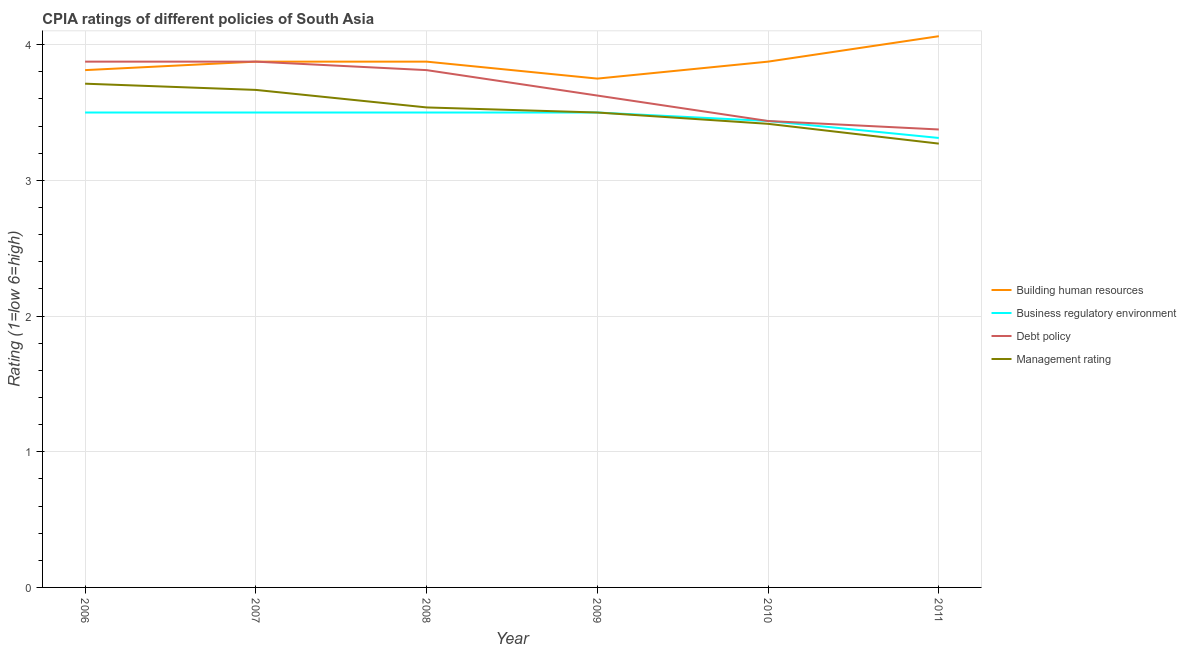How many different coloured lines are there?
Your answer should be compact. 4. Does the line corresponding to cpia rating of management intersect with the line corresponding to cpia rating of building human resources?
Your response must be concise. No. Is the number of lines equal to the number of legend labels?
Your response must be concise. Yes. What is the cpia rating of building human resources in 2010?
Offer a terse response. 3.88. Across all years, what is the minimum cpia rating of debt policy?
Provide a short and direct response. 3.38. What is the total cpia rating of business regulatory environment in the graph?
Keep it short and to the point. 20.75. What is the difference between the cpia rating of debt policy in 2008 and that in 2009?
Offer a terse response. 0.19. What is the difference between the cpia rating of business regulatory environment in 2007 and the cpia rating of management in 2008?
Ensure brevity in your answer.  -0.04. What is the average cpia rating of building human resources per year?
Provide a short and direct response. 3.88. In the year 2009, what is the difference between the cpia rating of business regulatory environment and cpia rating of management?
Keep it short and to the point. 0. In how many years, is the cpia rating of building human resources greater than 3.8?
Make the answer very short. 5. What is the ratio of the cpia rating of building human resources in 2010 to that in 2011?
Provide a short and direct response. 0.95. What is the difference between the highest and the lowest cpia rating of management?
Keep it short and to the point. 0.44. Is the sum of the cpia rating of building human resources in 2006 and 2011 greater than the maximum cpia rating of management across all years?
Your answer should be very brief. Yes. Is it the case that in every year, the sum of the cpia rating of management and cpia rating of debt policy is greater than the sum of cpia rating of building human resources and cpia rating of business regulatory environment?
Your response must be concise. No. Is the cpia rating of management strictly less than the cpia rating of debt policy over the years?
Offer a very short reply. Yes. How many lines are there?
Keep it short and to the point. 4. Are the values on the major ticks of Y-axis written in scientific E-notation?
Offer a terse response. No. Does the graph contain any zero values?
Offer a very short reply. No. Does the graph contain grids?
Provide a succinct answer. Yes. Where does the legend appear in the graph?
Ensure brevity in your answer.  Center right. How many legend labels are there?
Your answer should be compact. 4. What is the title of the graph?
Offer a very short reply. CPIA ratings of different policies of South Asia. What is the label or title of the X-axis?
Offer a terse response. Year. What is the Rating (1=low 6=high) in Building human resources in 2006?
Your answer should be compact. 3.81. What is the Rating (1=low 6=high) of Debt policy in 2006?
Keep it short and to the point. 3.88. What is the Rating (1=low 6=high) in Management rating in 2006?
Keep it short and to the point. 3.71. What is the Rating (1=low 6=high) in Building human resources in 2007?
Your response must be concise. 3.88. What is the Rating (1=low 6=high) in Debt policy in 2007?
Ensure brevity in your answer.  3.88. What is the Rating (1=low 6=high) in Management rating in 2007?
Your answer should be very brief. 3.67. What is the Rating (1=low 6=high) in Building human resources in 2008?
Provide a succinct answer. 3.88. What is the Rating (1=low 6=high) of Business regulatory environment in 2008?
Keep it short and to the point. 3.5. What is the Rating (1=low 6=high) in Debt policy in 2008?
Offer a terse response. 3.81. What is the Rating (1=low 6=high) in Management rating in 2008?
Give a very brief answer. 3.54. What is the Rating (1=low 6=high) of Building human resources in 2009?
Give a very brief answer. 3.75. What is the Rating (1=low 6=high) in Business regulatory environment in 2009?
Keep it short and to the point. 3.5. What is the Rating (1=low 6=high) of Debt policy in 2009?
Ensure brevity in your answer.  3.62. What is the Rating (1=low 6=high) of Management rating in 2009?
Keep it short and to the point. 3.5. What is the Rating (1=low 6=high) of Building human resources in 2010?
Your answer should be very brief. 3.88. What is the Rating (1=low 6=high) in Business regulatory environment in 2010?
Offer a very short reply. 3.44. What is the Rating (1=low 6=high) of Debt policy in 2010?
Make the answer very short. 3.44. What is the Rating (1=low 6=high) in Management rating in 2010?
Your answer should be very brief. 3.42. What is the Rating (1=low 6=high) of Building human resources in 2011?
Provide a succinct answer. 4.06. What is the Rating (1=low 6=high) of Business regulatory environment in 2011?
Provide a short and direct response. 3.31. What is the Rating (1=low 6=high) of Debt policy in 2011?
Your response must be concise. 3.38. What is the Rating (1=low 6=high) of Management rating in 2011?
Offer a very short reply. 3.27. Across all years, what is the maximum Rating (1=low 6=high) of Building human resources?
Your answer should be very brief. 4.06. Across all years, what is the maximum Rating (1=low 6=high) in Business regulatory environment?
Offer a terse response. 3.5. Across all years, what is the maximum Rating (1=low 6=high) of Debt policy?
Make the answer very short. 3.88. Across all years, what is the maximum Rating (1=low 6=high) of Management rating?
Offer a terse response. 3.71. Across all years, what is the minimum Rating (1=low 6=high) of Building human resources?
Offer a terse response. 3.75. Across all years, what is the minimum Rating (1=low 6=high) in Business regulatory environment?
Your answer should be compact. 3.31. Across all years, what is the minimum Rating (1=low 6=high) in Debt policy?
Give a very brief answer. 3.38. Across all years, what is the minimum Rating (1=low 6=high) in Management rating?
Give a very brief answer. 3.27. What is the total Rating (1=low 6=high) in Building human resources in the graph?
Provide a succinct answer. 23.25. What is the total Rating (1=low 6=high) of Business regulatory environment in the graph?
Give a very brief answer. 20.75. What is the total Rating (1=low 6=high) in Management rating in the graph?
Your answer should be very brief. 21.1. What is the difference between the Rating (1=low 6=high) in Building human resources in 2006 and that in 2007?
Your response must be concise. -0.06. What is the difference between the Rating (1=low 6=high) in Business regulatory environment in 2006 and that in 2007?
Give a very brief answer. 0. What is the difference between the Rating (1=low 6=high) of Management rating in 2006 and that in 2007?
Your response must be concise. 0.05. What is the difference between the Rating (1=low 6=high) in Building human resources in 2006 and that in 2008?
Your response must be concise. -0.06. What is the difference between the Rating (1=low 6=high) in Business regulatory environment in 2006 and that in 2008?
Your answer should be compact. 0. What is the difference between the Rating (1=low 6=high) of Debt policy in 2006 and that in 2008?
Offer a very short reply. 0.06. What is the difference between the Rating (1=low 6=high) of Management rating in 2006 and that in 2008?
Provide a short and direct response. 0.17. What is the difference between the Rating (1=low 6=high) of Building human resources in 2006 and that in 2009?
Offer a very short reply. 0.06. What is the difference between the Rating (1=low 6=high) in Debt policy in 2006 and that in 2009?
Provide a succinct answer. 0.25. What is the difference between the Rating (1=low 6=high) of Management rating in 2006 and that in 2009?
Your response must be concise. 0.21. What is the difference between the Rating (1=low 6=high) of Building human resources in 2006 and that in 2010?
Offer a very short reply. -0.06. What is the difference between the Rating (1=low 6=high) in Business regulatory environment in 2006 and that in 2010?
Give a very brief answer. 0.06. What is the difference between the Rating (1=low 6=high) in Debt policy in 2006 and that in 2010?
Provide a short and direct response. 0.44. What is the difference between the Rating (1=low 6=high) of Management rating in 2006 and that in 2010?
Offer a very short reply. 0.3. What is the difference between the Rating (1=low 6=high) of Building human resources in 2006 and that in 2011?
Your response must be concise. -0.25. What is the difference between the Rating (1=low 6=high) of Business regulatory environment in 2006 and that in 2011?
Ensure brevity in your answer.  0.19. What is the difference between the Rating (1=low 6=high) of Management rating in 2006 and that in 2011?
Your answer should be compact. 0.44. What is the difference between the Rating (1=low 6=high) of Debt policy in 2007 and that in 2008?
Give a very brief answer. 0.06. What is the difference between the Rating (1=low 6=high) in Management rating in 2007 and that in 2008?
Provide a short and direct response. 0.13. What is the difference between the Rating (1=low 6=high) in Business regulatory environment in 2007 and that in 2009?
Your response must be concise. 0. What is the difference between the Rating (1=low 6=high) in Debt policy in 2007 and that in 2009?
Provide a succinct answer. 0.25. What is the difference between the Rating (1=low 6=high) of Business regulatory environment in 2007 and that in 2010?
Offer a very short reply. 0.06. What is the difference between the Rating (1=low 6=high) of Debt policy in 2007 and that in 2010?
Offer a terse response. 0.44. What is the difference between the Rating (1=low 6=high) in Building human resources in 2007 and that in 2011?
Your response must be concise. -0.19. What is the difference between the Rating (1=low 6=high) in Business regulatory environment in 2007 and that in 2011?
Offer a terse response. 0.19. What is the difference between the Rating (1=low 6=high) in Debt policy in 2007 and that in 2011?
Your answer should be compact. 0.5. What is the difference between the Rating (1=low 6=high) of Management rating in 2007 and that in 2011?
Keep it short and to the point. 0.4. What is the difference between the Rating (1=low 6=high) in Building human resources in 2008 and that in 2009?
Make the answer very short. 0.12. What is the difference between the Rating (1=low 6=high) in Business regulatory environment in 2008 and that in 2009?
Offer a terse response. 0. What is the difference between the Rating (1=low 6=high) in Debt policy in 2008 and that in 2009?
Provide a succinct answer. 0.19. What is the difference between the Rating (1=low 6=high) of Management rating in 2008 and that in 2009?
Keep it short and to the point. 0.04. What is the difference between the Rating (1=low 6=high) of Building human resources in 2008 and that in 2010?
Your answer should be very brief. 0. What is the difference between the Rating (1=low 6=high) in Business regulatory environment in 2008 and that in 2010?
Your answer should be very brief. 0.06. What is the difference between the Rating (1=low 6=high) in Debt policy in 2008 and that in 2010?
Ensure brevity in your answer.  0.38. What is the difference between the Rating (1=low 6=high) in Management rating in 2008 and that in 2010?
Offer a very short reply. 0.12. What is the difference between the Rating (1=low 6=high) of Building human resources in 2008 and that in 2011?
Offer a terse response. -0.19. What is the difference between the Rating (1=low 6=high) in Business regulatory environment in 2008 and that in 2011?
Provide a short and direct response. 0.19. What is the difference between the Rating (1=low 6=high) of Debt policy in 2008 and that in 2011?
Your answer should be very brief. 0.44. What is the difference between the Rating (1=low 6=high) in Management rating in 2008 and that in 2011?
Ensure brevity in your answer.  0.27. What is the difference between the Rating (1=low 6=high) in Building human resources in 2009 and that in 2010?
Offer a very short reply. -0.12. What is the difference between the Rating (1=low 6=high) of Business regulatory environment in 2009 and that in 2010?
Give a very brief answer. 0.06. What is the difference between the Rating (1=low 6=high) in Debt policy in 2009 and that in 2010?
Your answer should be very brief. 0.19. What is the difference between the Rating (1=low 6=high) of Management rating in 2009 and that in 2010?
Offer a terse response. 0.08. What is the difference between the Rating (1=low 6=high) of Building human resources in 2009 and that in 2011?
Offer a terse response. -0.31. What is the difference between the Rating (1=low 6=high) of Business regulatory environment in 2009 and that in 2011?
Offer a terse response. 0.19. What is the difference between the Rating (1=low 6=high) in Management rating in 2009 and that in 2011?
Make the answer very short. 0.23. What is the difference between the Rating (1=low 6=high) in Building human resources in 2010 and that in 2011?
Ensure brevity in your answer.  -0.19. What is the difference between the Rating (1=low 6=high) in Business regulatory environment in 2010 and that in 2011?
Your answer should be compact. 0.12. What is the difference between the Rating (1=low 6=high) of Debt policy in 2010 and that in 2011?
Your response must be concise. 0.06. What is the difference between the Rating (1=low 6=high) of Management rating in 2010 and that in 2011?
Give a very brief answer. 0.15. What is the difference between the Rating (1=low 6=high) of Building human resources in 2006 and the Rating (1=low 6=high) of Business regulatory environment in 2007?
Keep it short and to the point. 0.31. What is the difference between the Rating (1=low 6=high) in Building human resources in 2006 and the Rating (1=low 6=high) in Debt policy in 2007?
Give a very brief answer. -0.06. What is the difference between the Rating (1=low 6=high) in Building human resources in 2006 and the Rating (1=low 6=high) in Management rating in 2007?
Offer a terse response. 0.15. What is the difference between the Rating (1=low 6=high) in Business regulatory environment in 2006 and the Rating (1=low 6=high) in Debt policy in 2007?
Ensure brevity in your answer.  -0.38. What is the difference between the Rating (1=low 6=high) in Business regulatory environment in 2006 and the Rating (1=low 6=high) in Management rating in 2007?
Your answer should be compact. -0.17. What is the difference between the Rating (1=low 6=high) of Debt policy in 2006 and the Rating (1=low 6=high) of Management rating in 2007?
Give a very brief answer. 0.21. What is the difference between the Rating (1=low 6=high) of Building human resources in 2006 and the Rating (1=low 6=high) of Business regulatory environment in 2008?
Offer a terse response. 0.31. What is the difference between the Rating (1=low 6=high) in Building human resources in 2006 and the Rating (1=low 6=high) in Debt policy in 2008?
Offer a very short reply. 0. What is the difference between the Rating (1=low 6=high) in Building human resources in 2006 and the Rating (1=low 6=high) in Management rating in 2008?
Provide a short and direct response. 0.28. What is the difference between the Rating (1=low 6=high) in Business regulatory environment in 2006 and the Rating (1=low 6=high) in Debt policy in 2008?
Offer a terse response. -0.31. What is the difference between the Rating (1=low 6=high) in Business regulatory environment in 2006 and the Rating (1=low 6=high) in Management rating in 2008?
Your response must be concise. -0.04. What is the difference between the Rating (1=low 6=high) of Debt policy in 2006 and the Rating (1=low 6=high) of Management rating in 2008?
Your response must be concise. 0.34. What is the difference between the Rating (1=low 6=high) in Building human resources in 2006 and the Rating (1=low 6=high) in Business regulatory environment in 2009?
Give a very brief answer. 0.31. What is the difference between the Rating (1=low 6=high) in Building human resources in 2006 and the Rating (1=low 6=high) in Debt policy in 2009?
Keep it short and to the point. 0.19. What is the difference between the Rating (1=low 6=high) of Building human resources in 2006 and the Rating (1=low 6=high) of Management rating in 2009?
Your answer should be compact. 0.31. What is the difference between the Rating (1=low 6=high) in Business regulatory environment in 2006 and the Rating (1=low 6=high) in Debt policy in 2009?
Offer a terse response. -0.12. What is the difference between the Rating (1=low 6=high) in Building human resources in 2006 and the Rating (1=low 6=high) in Business regulatory environment in 2010?
Your answer should be compact. 0.38. What is the difference between the Rating (1=low 6=high) in Building human resources in 2006 and the Rating (1=low 6=high) in Debt policy in 2010?
Your response must be concise. 0.38. What is the difference between the Rating (1=low 6=high) of Building human resources in 2006 and the Rating (1=low 6=high) of Management rating in 2010?
Your response must be concise. 0.4. What is the difference between the Rating (1=low 6=high) of Business regulatory environment in 2006 and the Rating (1=low 6=high) of Debt policy in 2010?
Your response must be concise. 0.06. What is the difference between the Rating (1=low 6=high) of Business regulatory environment in 2006 and the Rating (1=low 6=high) of Management rating in 2010?
Your answer should be very brief. 0.08. What is the difference between the Rating (1=low 6=high) of Debt policy in 2006 and the Rating (1=low 6=high) of Management rating in 2010?
Your answer should be very brief. 0.46. What is the difference between the Rating (1=low 6=high) of Building human resources in 2006 and the Rating (1=low 6=high) of Debt policy in 2011?
Provide a short and direct response. 0.44. What is the difference between the Rating (1=low 6=high) in Building human resources in 2006 and the Rating (1=low 6=high) in Management rating in 2011?
Offer a terse response. 0.54. What is the difference between the Rating (1=low 6=high) in Business regulatory environment in 2006 and the Rating (1=low 6=high) in Debt policy in 2011?
Keep it short and to the point. 0.12. What is the difference between the Rating (1=low 6=high) of Business regulatory environment in 2006 and the Rating (1=low 6=high) of Management rating in 2011?
Your answer should be compact. 0.23. What is the difference between the Rating (1=low 6=high) in Debt policy in 2006 and the Rating (1=low 6=high) in Management rating in 2011?
Offer a terse response. 0.6. What is the difference between the Rating (1=low 6=high) in Building human resources in 2007 and the Rating (1=low 6=high) in Business regulatory environment in 2008?
Your answer should be compact. 0.38. What is the difference between the Rating (1=low 6=high) of Building human resources in 2007 and the Rating (1=low 6=high) of Debt policy in 2008?
Keep it short and to the point. 0.06. What is the difference between the Rating (1=low 6=high) in Building human resources in 2007 and the Rating (1=low 6=high) in Management rating in 2008?
Provide a succinct answer. 0.34. What is the difference between the Rating (1=low 6=high) of Business regulatory environment in 2007 and the Rating (1=low 6=high) of Debt policy in 2008?
Ensure brevity in your answer.  -0.31. What is the difference between the Rating (1=low 6=high) of Business regulatory environment in 2007 and the Rating (1=low 6=high) of Management rating in 2008?
Ensure brevity in your answer.  -0.04. What is the difference between the Rating (1=low 6=high) in Debt policy in 2007 and the Rating (1=low 6=high) in Management rating in 2008?
Your answer should be compact. 0.34. What is the difference between the Rating (1=low 6=high) of Building human resources in 2007 and the Rating (1=low 6=high) of Business regulatory environment in 2009?
Provide a succinct answer. 0.38. What is the difference between the Rating (1=low 6=high) of Building human resources in 2007 and the Rating (1=low 6=high) of Management rating in 2009?
Provide a short and direct response. 0.38. What is the difference between the Rating (1=low 6=high) in Business regulatory environment in 2007 and the Rating (1=low 6=high) in Debt policy in 2009?
Your response must be concise. -0.12. What is the difference between the Rating (1=low 6=high) in Business regulatory environment in 2007 and the Rating (1=low 6=high) in Management rating in 2009?
Provide a short and direct response. 0. What is the difference between the Rating (1=low 6=high) of Building human resources in 2007 and the Rating (1=low 6=high) of Business regulatory environment in 2010?
Provide a succinct answer. 0.44. What is the difference between the Rating (1=low 6=high) of Building human resources in 2007 and the Rating (1=low 6=high) of Debt policy in 2010?
Provide a short and direct response. 0.44. What is the difference between the Rating (1=low 6=high) in Building human resources in 2007 and the Rating (1=low 6=high) in Management rating in 2010?
Provide a short and direct response. 0.46. What is the difference between the Rating (1=low 6=high) of Business regulatory environment in 2007 and the Rating (1=low 6=high) of Debt policy in 2010?
Provide a succinct answer. 0.06. What is the difference between the Rating (1=low 6=high) in Business regulatory environment in 2007 and the Rating (1=low 6=high) in Management rating in 2010?
Make the answer very short. 0.08. What is the difference between the Rating (1=low 6=high) in Debt policy in 2007 and the Rating (1=low 6=high) in Management rating in 2010?
Offer a terse response. 0.46. What is the difference between the Rating (1=low 6=high) in Building human resources in 2007 and the Rating (1=low 6=high) in Business regulatory environment in 2011?
Your answer should be compact. 0.56. What is the difference between the Rating (1=low 6=high) of Building human resources in 2007 and the Rating (1=low 6=high) of Management rating in 2011?
Offer a terse response. 0.6. What is the difference between the Rating (1=low 6=high) in Business regulatory environment in 2007 and the Rating (1=low 6=high) in Management rating in 2011?
Make the answer very short. 0.23. What is the difference between the Rating (1=low 6=high) of Debt policy in 2007 and the Rating (1=low 6=high) of Management rating in 2011?
Provide a short and direct response. 0.6. What is the difference between the Rating (1=low 6=high) in Building human resources in 2008 and the Rating (1=low 6=high) in Management rating in 2009?
Keep it short and to the point. 0.38. What is the difference between the Rating (1=low 6=high) of Business regulatory environment in 2008 and the Rating (1=low 6=high) of Debt policy in 2009?
Your answer should be compact. -0.12. What is the difference between the Rating (1=low 6=high) of Business regulatory environment in 2008 and the Rating (1=low 6=high) of Management rating in 2009?
Keep it short and to the point. 0. What is the difference between the Rating (1=low 6=high) of Debt policy in 2008 and the Rating (1=low 6=high) of Management rating in 2009?
Your answer should be very brief. 0.31. What is the difference between the Rating (1=low 6=high) in Building human resources in 2008 and the Rating (1=low 6=high) in Business regulatory environment in 2010?
Provide a short and direct response. 0.44. What is the difference between the Rating (1=low 6=high) in Building human resources in 2008 and the Rating (1=low 6=high) in Debt policy in 2010?
Offer a very short reply. 0.44. What is the difference between the Rating (1=low 6=high) of Building human resources in 2008 and the Rating (1=low 6=high) of Management rating in 2010?
Keep it short and to the point. 0.46. What is the difference between the Rating (1=low 6=high) of Business regulatory environment in 2008 and the Rating (1=low 6=high) of Debt policy in 2010?
Your answer should be very brief. 0.06. What is the difference between the Rating (1=low 6=high) of Business regulatory environment in 2008 and the Rating (1=low 6=high) of Management rating in 2010?
Keep it short and to the point. 0.08. What is the difference between the Rating (1=low 6=high) of Debt policy in 2008 and the Rating (1=low 6=high) of Management rating in 2010?
Provide a short and direct response. 0.4. What is the difference between the Rating (1=low 6=high) in Building human resources in 2008 and the Rating (1=low 6=high) in Business regulatory environment in 2011?
Keep it short and to the point. 0.56. What is the difference between the Rating (1=low 6=high) in Building human resources in 2008 and the Rating (1=low 6=high) in Management rating in 2011?
Your response must be concise. 0.6. What is the difference between the Rating (1=low 6=high) of Business regulatory environment in 2008 and the Rating (1=low 6=high) of Debt policy in 2011?
Your answer should be very brief. 0.12. What is the difference between the Rating (1=low 6=high) in Business regulatory environment in 2008 and the Rating (1=low 6=high) in Management rating in 2011?
Offer a very short reply. 0.23. What is the difference between the Rating (1=low 6=high) in Debt policy in 2008 and the Rating (1=low 6=high) in Management rating in 2011?
Give a very brief answer. 0.54. What is the difference between the Rating (1=low 6=high) in Building human resources in 2009 and the Rating (1=low 6=high) in Business regulatory environment in 2010?
Provide a short and direct response. 0.31. What is the difference between the Rating (1=low 6=high) of Building human resources in 2009 and the Rating (1=low 6=high) of Debt policy in 2010?
Offer a very short reply. 0.31. What is the difference between the Rating (1=low 6=high) in Business regulatory environment in 2009 and the Rating (1=low 6=high) in Debt policy in 2010?
Your response must be concise. 0.06. What is the difference between the Rating (1=low 6=high) of Business regulatory environment in 2009 and the Rating (1=low 6=high) of Management rating in 2010?
Give a very brief answer. 0.08. What is the difference between the Rating (1=low 6=high) in Debt policy in 2009 and the Rating (1=low 6=high) in Management rating in 2010?
Offer a terse response. 0.21. What is the difference between the Rating (1=low 6=high) in Building human resources in 2009 and the Rating (1=low 6=high) in Business regulatory environment in 2011?
Make the answer very short. 0.44. What is the difference between the Rating (1=low 6=high) in Building human resources in 2009 and the Rating (1=low 6=high) in Debt policy in 2011?
Your answer should be very brief. 0.38. What is the difference between the Rating (1=low 6=high) of Building human resources in 2009 and the Rating (1=low 6=high) of Management rating in 2011?
Provide a succinct answer. 0.48. What is the difference between the Rating (1=low 6=high) in Business regulatory environment in 2009 and the Rating (1=low 6=high) in Debt policy in 2011?
Keep it short and to the point. 0.12. What is the difference between the Rating (1=low 6=high) of Business regulatory environment in 2009 and the Rating (1=low 6=high) of Management rating in 2011?
Your answer should be very brief. 0.23. What is the difference between the Rating (1=low 6=high) of Debt policy in 2009 and the Rating (1=low 6=high) of Management rating in 2011?
Give a very brief answer. 0.35. What is the difference between the Rating (1=low 6=high) of Building human resources in 2010 and the Rating (1=low 6=high) of Business regulatory environment in 2011?
Your answer should be compact. 0.56. What is the difference between the Rating (1=low 6=high) of Building human resources in 2010 and the Rating (1=low 6=high) of Management rating in 2011?
Your response must be concise. 0.6. What is the difference between the Rating (1=low 6=high) in Business regulatory environment in 2010 and the Rating (1=low 6=high) in Debt policy in 2011?
Provide a short and direct response. 0.06. What is the average Rating (1=low 6=high) in Building human resources per year?
Provide a short and direct response. 3.88. What is the average Rating (1=low 6=high) in Business regulatory environment per year?
Give a very brief answer. 3.46. What is the average Rating (1=low 6=high) in Debt policy per year?
Offer a very short reply. 3.67. What is the average Rating (1=low 6=high) in Management rating per year?
Your answer should be compact. 3.52. In the year 2006, what is the difference between the Rating (1=low 6=high) of Building human resources and Rating (1=low 6=high) of Business regulatory environment?
Your answer should be compact. 0.31. In the year 2006, what is the difference between the Rating (1=low 6=high) of Building human resources and Rating (1=low 6=high) of Debt policy?
Provide a short and direct response. -0.06. In the year 2006, what is the difference between the Rating (1=low 6=high) in Building human resources and Rating (1=low 6=high) in Management rating?
Offer a very short reply. 0.1. In the year 2006, what is the difference between the Rating (1=low 6=high) of Business regulatory environment and Rating (1=low 6=high) of Debt policy?
Your answer should be compact. -0.38. In the year 2006, what is the difference between the Rating (1=low 6=high) in Business regulatory environment and Rating (1=low 6=high) in Management rating?
Offer a very short reply. -0.21. In the year 2006, what is the difference between the Rating (1=low 6=high) in Debt policy and Rating (1=low 6=high) in Management rating?
Your answer should be compact. 0.16. In the year 2007, what is the difference between the Rating (1=low 6=high) of Building human resources and Rating (1=low 6=high) of Business regulatory environment?
Provide a short and direct response. 0.38. In the year 2007, what is the difference between the Rating (1=low 6=high) of Building human resources and Rating (1=low 6=high) of Management rating?
Make the answer very short. 0.21. In the year 2007, what is the difference between the Rating (1=low 6=high) in Business regulatory environment and Rating (1=low 6=high) in Debt policy?
Give a very brief answer. -0.38. In the year 2007, what is the difference between the Rating (1=low 6=high) of Business regulatory environment and Rating (1=low 6=high) of Management rating?
Give a very brief answer. -0.17. In the year 2007, what is the difference between the Rating (1=low 6=high) in Debt policy and Rating (1=low 6=high) in Management rating?
Ensure brevity in your answer.  0.21. In the year 2008, what is the difference between the Rating (1=low 6=high) of Building human resources and Rating (1=low 6=high) of Business regulatory environment?
Provide a succinct answer. 0.38. In the year 2008, what is the difference between the Rating (1=low 6=high) of Building human resources and Rating (1=low 6=high) of Debt policy?
Offer a terse response. 0.06. In the year 2008, what is the difference between the Rating (1=low 6=high) of Building human resources and Rating (1=low 6=high) of Management rating?
Your response must be concise. 0.34. In the year 2008, what is the difference between the Rating (1=low 6=high) of Business regulatory environment and Rating (1=low 6=high) of Debt policy?
Offer a terse response. -0.31. In the year 2008, what is the difference between the Rating (1=low 6=high) in Business regulatory environment and Rating (1=low 6=high) in Management rating?
Provide a succinct answer. -0.04. In the year 2008, what is the difference between the Rating (1=low 6=high) in Debt policy and Rating (1=low 6=high) in Management rating?
Keep it short and to the point. 0.28. In the year 2009, what is the difference between the Rating (1=low 6=high) of Building human resources and Rating (1=low 6=high) of Business regulatory environment?
Your answer should be very brief. 0.25. In the year 2009, what is the difference between the Rating (1=low 6=high) in Building human resources and Rating (1=low 6=high) in Debt policy?
Provide a succinct answer. 0.12. In the year 2009, what is the difference between the Rating (1=low 6=high) of Business regulatory environment and Rating (1=low 6=high) of Debt policy?
Your answer should be compact. -0.12. In the year 2009, what is the difference between the Rating (1=low 6=high) in Business regulatory environment and Rating (1=low 6=high) in Management rating?
Offer a terse response. 0. In the year 2010, what is the difference between the Rating (1=low 6=high) in Building human resources and Rating (1=low 6=high) in Business regulatory environment?
Ensure brevity in your answer.  0.44. In the year 2010, what is the difference between the Rating (1=low 6=high) of Building human resources and Rating (1=low 6=high) of Debt policy?
Give a very brief answer. 0.44. In the year 2010, what is the difference between the Rating (1=low 6=high) of Building human resources and Rating (1=low 6=high) of Management rating?
Keep it short and to the point. 0.46. In the year 2010, what is the difference between the Rating (1=low 6=high) of Business regulatory environment and Rating (1=low 6=high) of Debt policy?
Offer a very short reply. 0. In the year 2010, what is the difference between the Rating (1=low 6=high) of Business regulatory environment and Rating (1=low 6=high) of Management rating?
Your answer should be compact. 0.02. In the year 2010, what is the difference between the Rating (1=low 6=high) of Debt policy and Rating (1=low 6=high) of Management rating?
Offer a terse response. 0.02. In the year 2011, what is the difference between the Rating (1=low 6=high) of Building human resources and Rating (1=low 6=high) of Business regulatory environment?
Ensure brevity in your answer.  0.75. In the year 2011, what is the difference between the Rating (1=low 6=high) in Building human resources and Rating (1=low 6=high) in Debt policy?
Offer a terse response. 0.69. In the year 2011, what is the difference between the Rating (1=low 6=high) in Building human resources and Rating (1=low 6=high) in Management rating?
Your answer should be very brief. 0.79. In the year 2011, what is the difference between the Rating (1=low 6=high) of Business regulatory environment and Rating (1=low 6=high) of Debt policy?
Offer a terse response. -0.06. In the year 2011, what is the difference between the Rating (1=low 6=high) in Business regulatory environment and Rating (1=low 6=high) in Management rating?
Provide a succinct answer. 0.04. In the year 2011, what is the difference between the Rating (1=low 6=high) in Debt policy and Rating (1=low 6=high) in Management rating?
Your response must be concise. 0.1. What is the ratio of the Rating (1=low 6=high) in Building human resources in 2006 to that in 2007?
Your answer should be very brief. 0.98. What is the ratio of the Rating (1=low 6=high) in Management rating in 2006 to that in 2007?
Keep it short and to the point. 1.01. What is the ratio of the Rating (1=low 6=high) in Building human resources in 2006 to that in 2008?
Offer a very short reply. 0.98. What is the ratio of the Rating (1=low 6=high) in Debt policy in 2006 to that in 2008?
Your answer should be compact. 1.02. What is the ratio of the Rating (1=low 6=high) in Management rating in 2006 to that in 2008?
Ensure brevity in your answer.  1.05. What is the ratio of the Rating (1=low 6=high) in Building human resources in 2006 to that in 2009?
Offer a very short reply. 1.02. What is the ratio of the Rating (1=low 6=high) in Business regulatory environment in 2006 to that in 2009?
Your answer should be compact. 1. What is the ratio of the Rating (1=low 6=high) in Debt policy in 2006 to that in 2009?
Your answer should be very brief. 1.07. What is the ratio of the Rating (1=low 6=high) in Management rating in 2006 to that in 2009?
Make the answer very short. 1.06. What is the ratio of the Rating (1=low 6=high) in Building human resources in 2006 to that in 2010?
Provide a short and direct response. 0.98. What is the ratio of the Rating (1=low 6=high) of Business regulatory environment in 2006 to that in 2010?
Keep it short and to the point. 1.02. What is the ratio of the Rating (1=low 6=high) in Debt policy in 2006 to that in 2010?
Make the answer very short. 1.13. What is the ratio of the Rating (1=low 6=high) in Management rating in 2006 to that in 2010?
Keep it short and to the point. 1.09. What is the ratio of the Rating (1=low 6=high) of Building human resources in 2006 to that in 2011?
Your answer should be very brief. 0.94. What is the ratio of the Rating (1=low 6=high) in Business regulatory environment in 2006 to that in 2011?
Provide a short and direct response. 1.06. What is the ratio of the Rating (1=low 6=high) of Debt policy in 2006 to that in 2011?
Your answer should be compact. 1.15. What is the ratio of the Rating (1=low 6=high) of Management rating in 2006 to that in 2011?
Give a very brief answer. 1.14. What is the ratio of the Rating (1=low 6=high) of Business regulatory environment in 2007 to that in 2008?
Ensure brevity in your answer.  1. What is the ratio of the Rating (1=low 6=high) in Debt policy in 2007 to that in 2008?
Keep it short and to the point. 1.02. What is the ratio of the Rating (1=low 6=high) of Management rating in 2007 to that in 2008?
Keep it short and to the point. 1.04. What is the ratio of the Rating (1=low 6=high) of Building human resources in 2007 to that in 2009?
Keep it short and to the point. 1.03. What is the ratio of the Rating (1=low 6=high) of Business regulatory environment in 2007 to that in 2009?
Your response must be concise. 1. What is the ratio of the Rating (1=low 6=high) of Debt policy in 2007 to that in 2009?
Offer a very short reply. 1.07. What is the ratio of the Rating (1=low 6=high) in Management rating in 2007 to that in 2009?
Provide a short and direct response. 1.05. What is the ratio of the Rating (1=low 6=high) in Business regulatory environment in 2007 to that in 2010?
Your answer should be very brief. 1.02. What is the ratio of the Rating (1=low 6=high) in Debt policy in 2007 to that in 2010?
Your answer should be compact. 1.13. What is the ratio of the Rating (1=low 6=high) in Management rating in 2007 to that in 2010?
Your answer should be compact. 1.07. What is the ratio of the Rating (1=low 6=high) of Building human resources in 2007 to that in 2011?
Keep it short and to the point. 0.95. What is the ratio of the Rating (1=low 6=high) of Business regulatory environment in 2007 to that in 2011?
Offer a very short reply. 1.06. What is the ratio of the Rating (1=low 6=high) of Debt policy in 2007 to that in 2011?
Give a very brief answer. 1.15. What is the ratio of the Rating (1=low 6=high) of Management rating in 2007 to that in 2011?
Your answer should be compact. 1.12. What is the ratio of the Rating (1=low 6=high) of Business regulatory environment in 2008 to that in 2009?
Offer a terse response. 1. What is the ratio of the Rating (1=low 6=high) of Debt policy in 2008 to that in 2009?
Keep it short and to the point. 1.05. What is the ratio of the Rating (1=low 6=high) in Management rating in 2008 to that in 2009?
Your answer should be very brief. 1.01. What is the ratio of the Rating (1=low 6=high) in Business regulatory environment in 2008 to that in 2010?
Make the answer very short. 1.02. What is the ratio of the Rating (1=low 6=high) of Debt policy in 2008 to that in 2010?
Offer a terse response. 1.11. What is the ratio of the Rating (1=low 6=high) of Management rating in 2008 to that in 2010?
Provide a short and direct response. 1.04. What is the ratio of the Rating (1=low 6=high) of Building human resources in 2008 to that in 2011?
Offer a very short reply. 0.95. What is the ratio of the Rating (1=low 6=high) in Business regulatory environment in 2008 to that in 2011?
Your answer should be very brief. 1.06. What is the ratio of the Rating (1=low 6=high) of Debt policy in 2008 to that in 2011?
Ensure brevity in your answer.  1.13. What is the ratio of the Rating (1=low 6=high) of Management rating in 2008 to that in 2011?
Make the answer very short. 1.08. What is the ratio of the Rating (1=low 6=high) of Building human resources in 2009 to that in 2010?
Offer a very short reply. 0.97. What is the ratio of the Rating (1=low 6=high) in Business regulatory environment in 2009 to that in 2010?
Offer a terse response. 1.02. What is the ratio of the Rating (1=low 6=high) in Debt policy in 2009 to that in 2010?
Your answer should be very brief. 1.05. What is the ratio of the Rating (1=low 6=high) in Management rating in 2009 to that in 2010?
Give a very brief answer. 1.02. What is the ratio of the Rating (1=low 6=high) in Building human resources in 2009 to that in 2011?
Offer a terse response. 0.92. What is the ratio of the Rating (1=low 6=high) in Business regulatory environment in 2009 to that in 2011?
Provide a succinct answer. 1.06. What is the ratio of the Rating (1=low 6=high) of Debt policy in 2009 to that in 2011?
Keep it short and to the point. 1.07. What is the ratio of the Rating (1=low 6=high) of Management rating in 2009 to that in 2011?
Provide a succinct answer. 1.07. What is the ratio of the Rating (1=low 6=high) in Building human resources in 2010 to that in 2011?
Provide a short and direct response. 0.95. What is the ratio of the Rating (1=low 6=high) in Business regulatory environment in 2010 to that in 2011?
Provide a short and direct response. 1.04. What is the ratio of the Rating (1=low 6=high) of Debt policy in 2010 to that in 2011?
Make the answer very short. 1.02. What is the ratio of the Rating (1=low 6=high) of Management rating in 2010 to that in 2011?
Offer a terse response. 1.04. What is the difference between the highest and the second highest Rating (1=low 6=high) of Building human resources?
Provide a short and direct response. 0.19. What is the difference between the highest and the second highest Rating (1=low 6=high) of Management rating?
Offer a very short reply. 0.05. What is the difference between the highest and the lowest Rating (1=low 6=high) in Building human resources?
Your answer should be very brief. 0.31. What is the difference between the highest and the lowest Rating (1=low 6=high) of Business regulatory environment?
Give a very brief answer. 0.19. What is the difference between the highest and the lowest Rating (1=low 6=high) of Debt policy?
Offer a very short reply. 0.5. What is the difference between the highest and the lowest Rating (1=low 6=high) of Management rating?
Your answer should be compact. 0.44. 